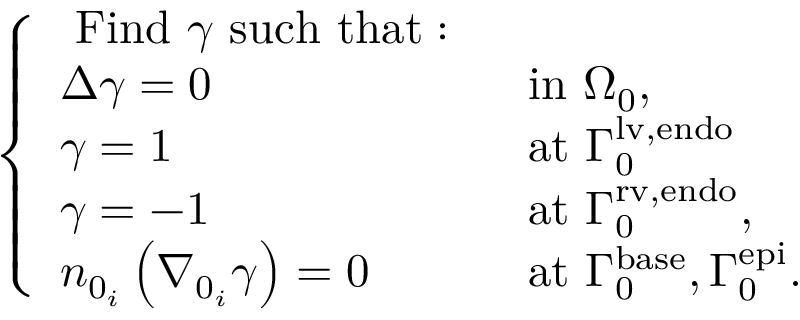<formula> <loc_0><loc_0><loc_500><loc_500>\left \{ \begin{array} { l l } { F i n d \gamma s u c h t h a t \colon } & \\ { \Delta \gamma = 0 } & { i n { \Omega } _ { 0 } , } \\ { \gamma = 1 } & { a t { \Gamma } _ { 0 } ^ { l v , e n d o } } \\ { \gamma = - 1 } & { a t { \Gamma } _ { 0 } ^ { r v , e n d o } , } \\ { n _ { 0 _ { i } } \left ( \nabla _ { 0 _ { i } } \gamma \right ) = 0 } & { a t { \Gamma } _ { 0 } ^ { b a s e } , { \Gamma } _ { 0 } ^ { e p i } . } \end{array}</formula> 